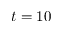<formula> <loc_0><loc_0><loc_500><loc_500>t = 1 0</formula> 